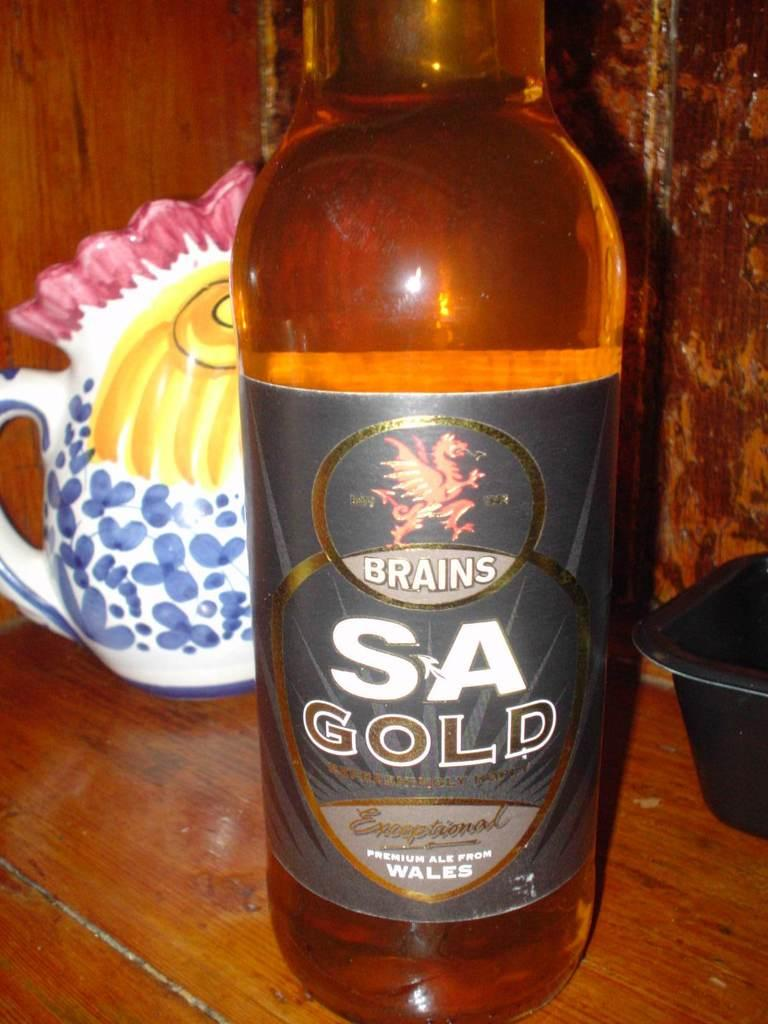Provide a one-sentence caption for the provided image. A bottle of Brains SA Gold sits on a table in front of a chicken-shaped pitcher. 